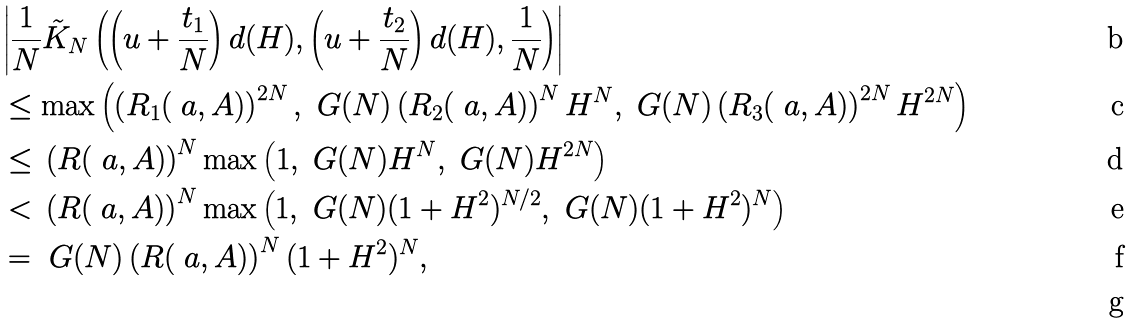<formula> <loc_0><loc_0><loc_500><loc_500>& \left | \frac { 1 } { N } \tilde { K } _ { N } \left ( \left ( u + \frac { t _ { 1 } } { N } \right ) d ( H ) , \left ( u + \frac { t _ { 2 } } { N } \right ) d ( H ) , \frac { 1 } { N } \right ) \right | \\ & \leq \max \left ( \left ( R _ { 1 } ( \ a , A ) \right ) ^ { 2 N } , \ G ( N ) \left ( R _ { 2 } ( \ a , A ) \right ) ^ { N } H ^ { N } , \ G ( N ) \left ( R _ { 3 } ( \ a , A ) \right ) ^ { 2 N } H ^ { 2 N } \right ) \\ & \leq \, \left ( R ( \ a , A ) \right ) ^ { N } \max \left ( 1 , \ G ( N ) H ^ { N } , \ G ( N ) H ^ { 2 N } \right ) \\ & < \, \left ( R ( \ a , A ) \right ) ^ { N } \max \left ( 1 , \ G ( N ) ( 1 + H ^ { 2 } ) ^ { N / 2 } , \ G ( N ) ( 1 + H ^ { 2 } ) ^ { N } \right ) \\ & = \ G ( N ) \left ( R ( \ a , A ) \right ) ^ { N } ( 1 + H ^ { 2 } ) ^ { N } , \\</formula> 